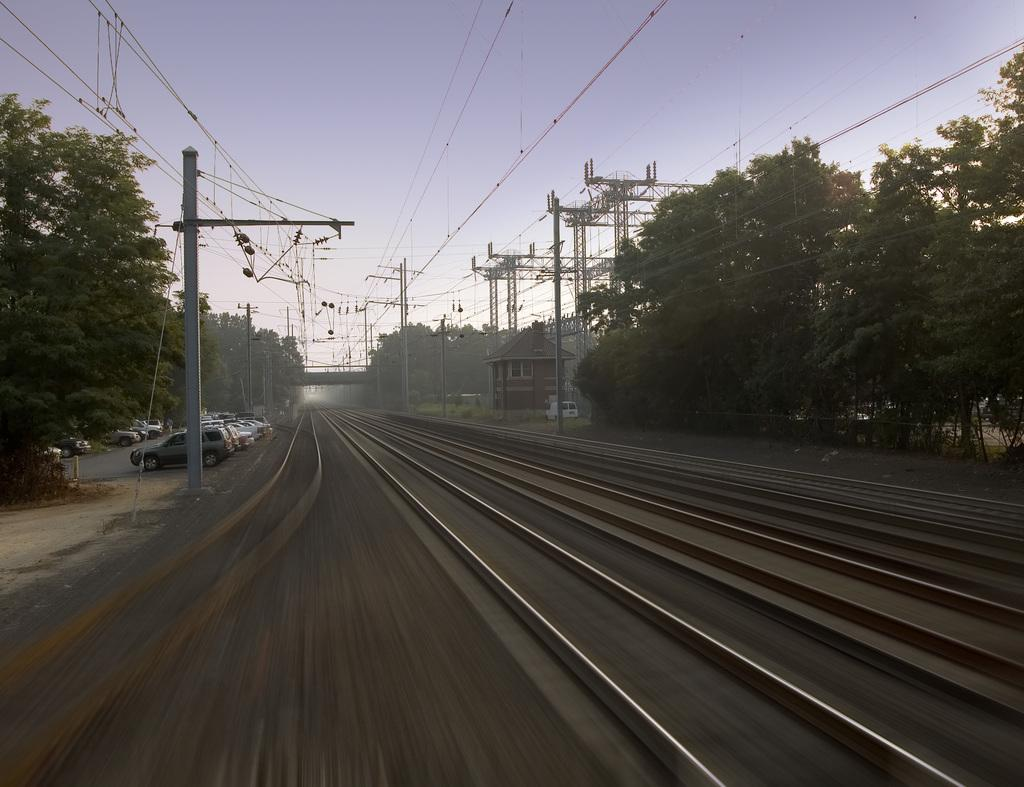What is located in the center of the image? There are train tracks in the center of the image. What can be seen on both sides of the train tracks? There are trees and poles with wires on both sides of the train tracks. What is visible on the left side of the image? There are vehicles visible on the left side of the image. What is visible at the top of the image? The sky is visible at the top of the image. What type of care is being provided to the trees in the image? There is no indication of any care being provided to the trees in the image; they are simply visible on both sides of the train tracks. 